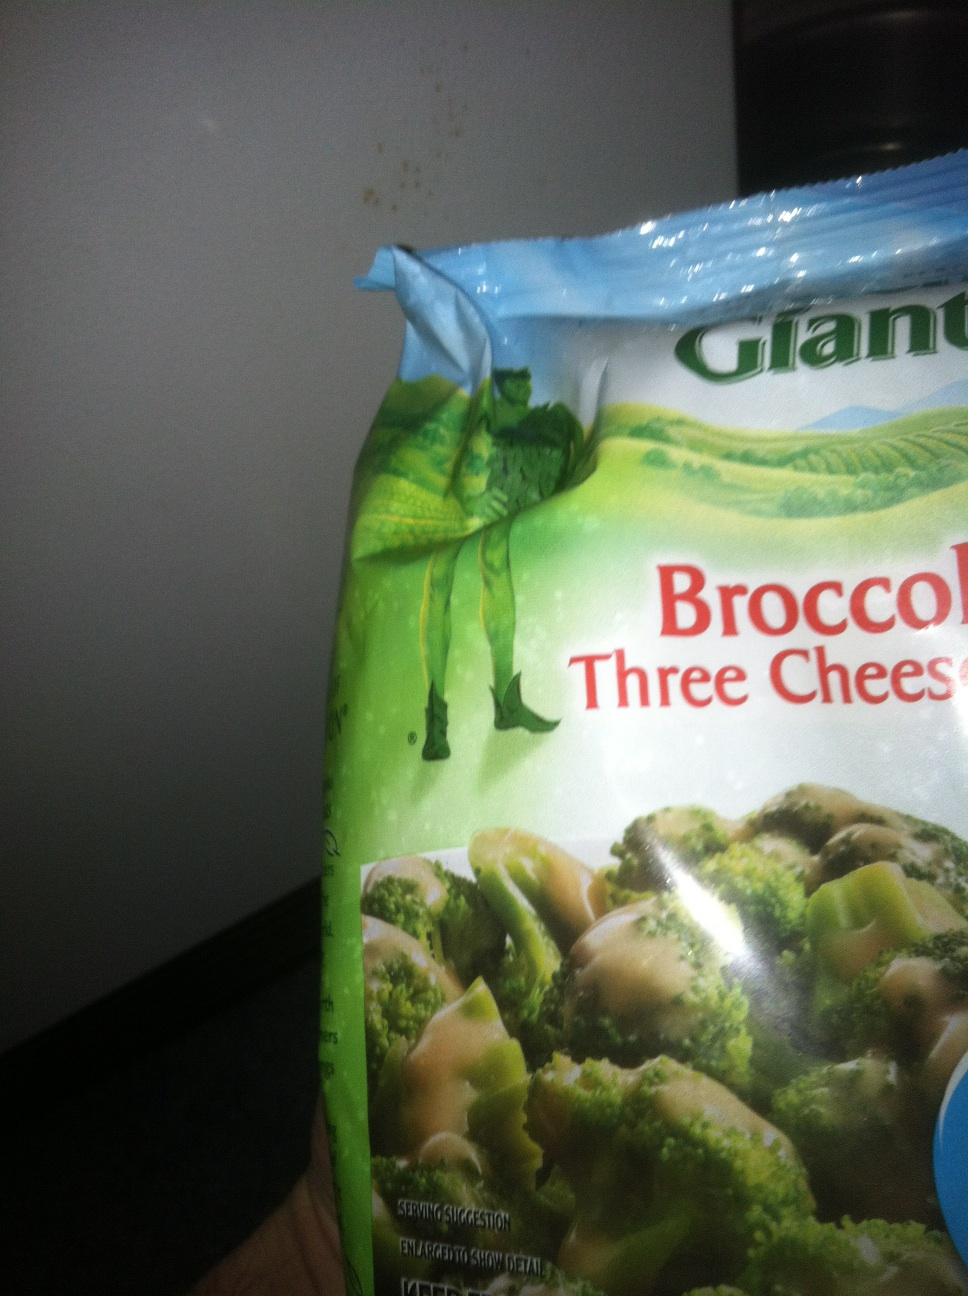Tell me a short and realistic use of this product in a recipe. A simple and delicious way to use this product is to microwave the broccoli three cheese sauce as instructed on the package and serve it as a side dish along with grilled chicken and rice. 